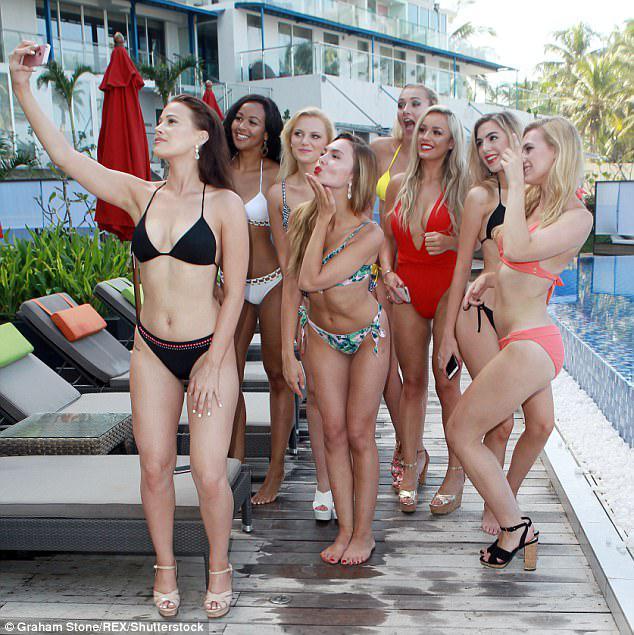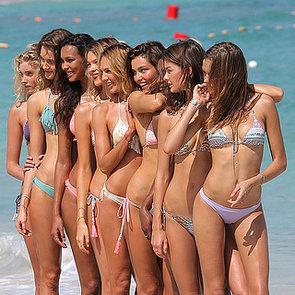The first image is the image on the left, the second image is the image on the right. Analyze the images presented: Is the assertion "In at least one image there are at least eight women in bikinis standing in a row." valid? Answer yes or no. Yes. 